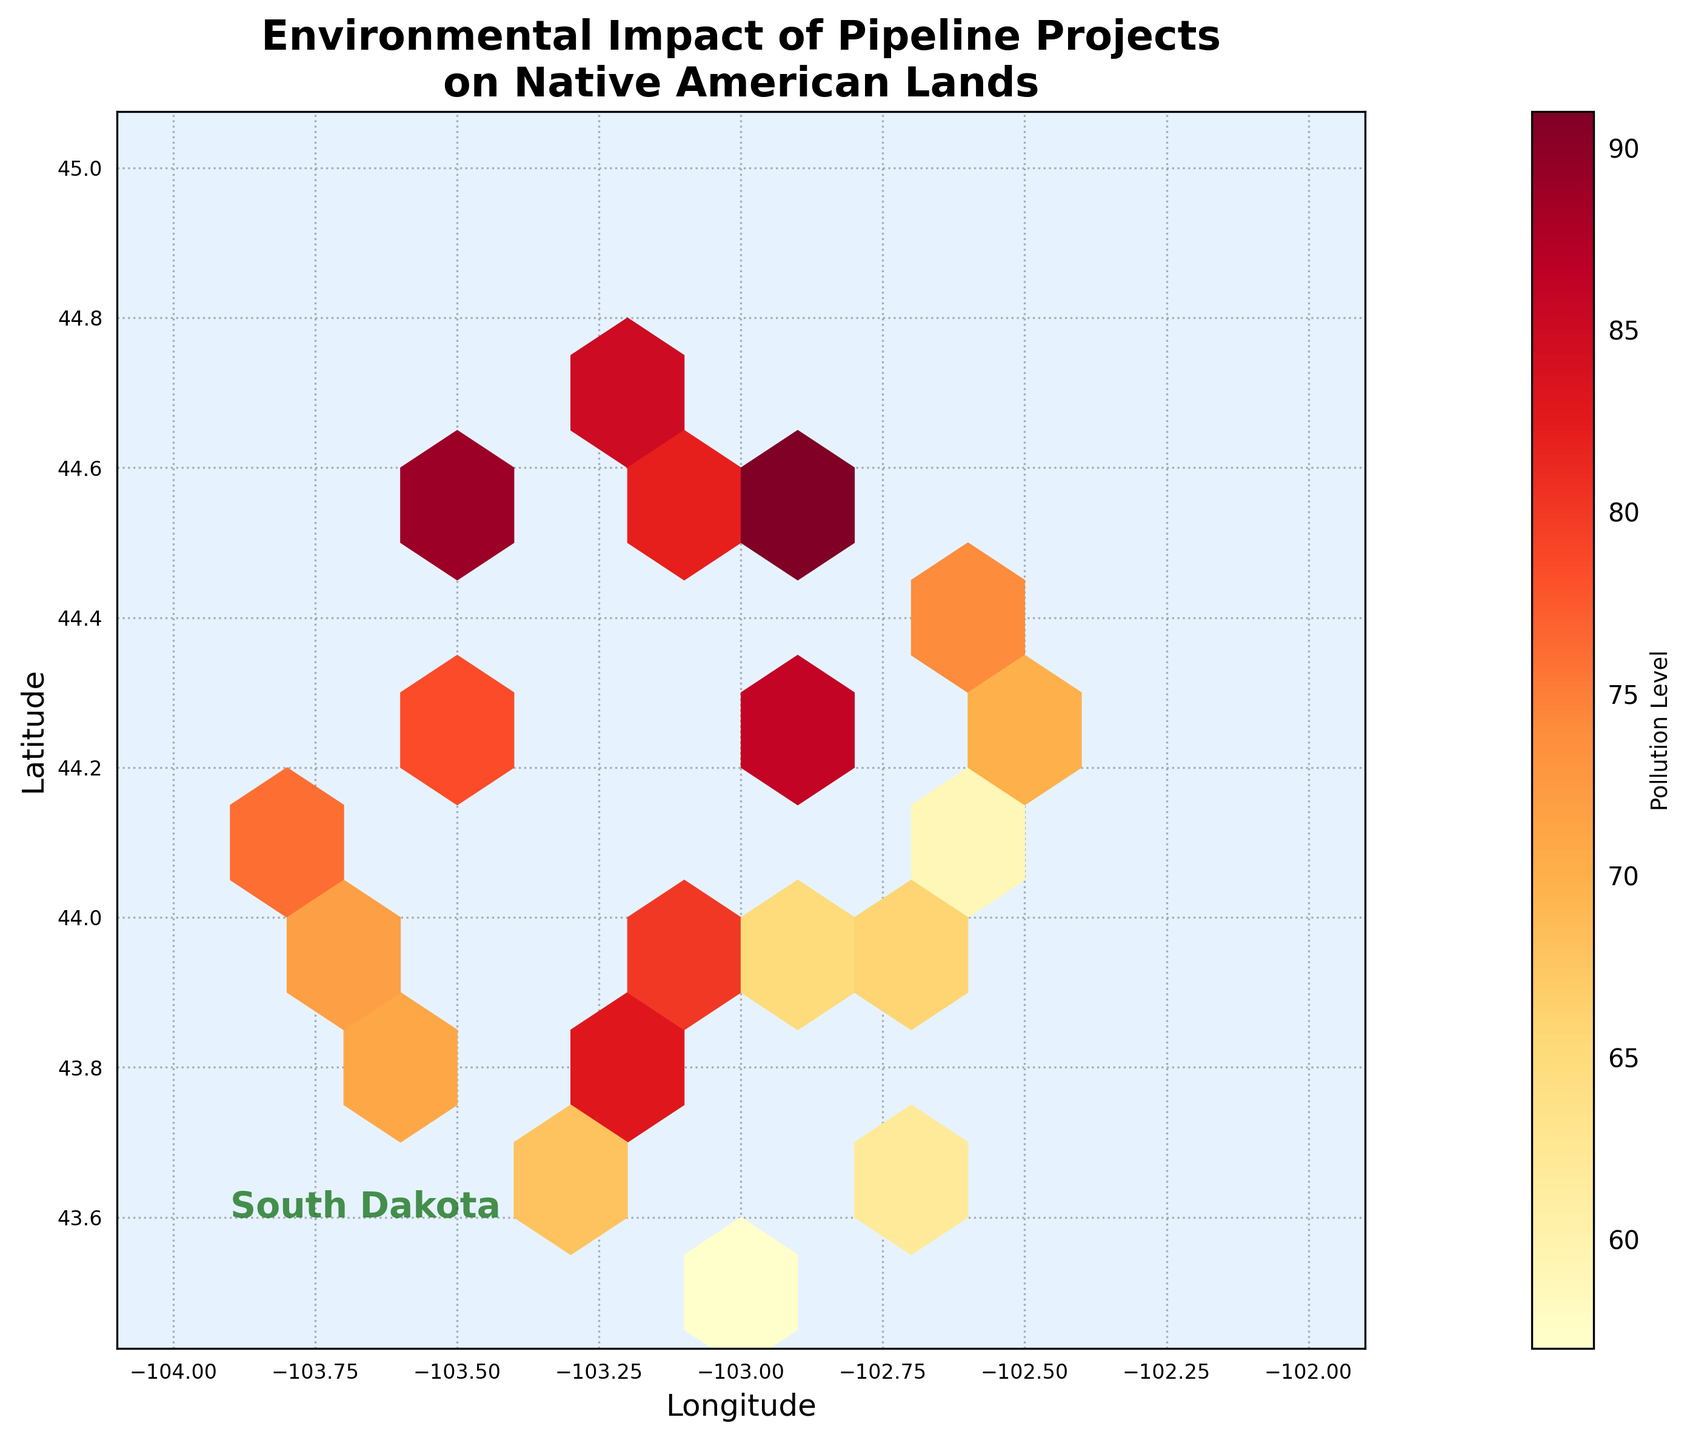What is the title of the plot? The title is prominently displayed at the top of the plot and reads "Environmental Impact of Pipeline Projects on Native American Lands"
Answer: Environmental Impact of Pipeline Projects on Native American Lands What do the colors in the hexagons represent? The color intensity in the hexagons represents the pollution level, with varying shades of YlOrRd (Yellow to Red) indicating different levels.
Answer: Pollution levels What are the labels of the x and y axes? The x-axis is labeled "Longitude" and the y-axis is labeled "Latitude" as indicated near the axes.
Answer: Longitude (x-axis), Latitude (y-axis) Where is the highest pollution level indicated on the hexbin plot? The highest pollution level is indicated by the darkest red hexagon. Looking at the color intensity, it appears to be located near longitude -102.8 and latitude 44.5.
Answer: Near -102.8 longitude and 44.5 latitude What does the color bar to the right of the plot indicate? The color bar shows the range of pollution levels with an annotated descriptor "Pollution Level" and ticks marking different levels from less polluted (lighter color) to more polluted (darker color).
Answer: Range of pollution levels How many main colors do you observe in the hexbin plot? The plot primarily uses a gradient of colors from yellow to dark red, representing different levels of pollution.
Answer: Gradient from yellow to dark red Is there a specific geographical region labeled in the plot? Yes, the plot has a label "South Dakota" located near longitude -103.9 and latitude 43.6.
Answer: South Dakota Which area shows a combination of both high and low pollution levels near each other? Around longitude -103.3 and latitude 44.2, there are hexagons that vary significantly in color intensity, indicating a mix of high and low pollution levels.
Answer: Near -103.3 longitude and 44.2 latitude Is there any hexbin location without pollution data? The plot generally shows populated hexagons across the area of interest, but some edge hexagons may be very light, indicating near-zero or no pollution data.
Answer: Some edge hexagons What is the general trend of pollution levels across the plotted region? The plot shows variation in pollution levels with clusters of high pollution particularly in the central and eastern parts of the plotted region.
Answer: Central and eastern areas have higher pollution levels 